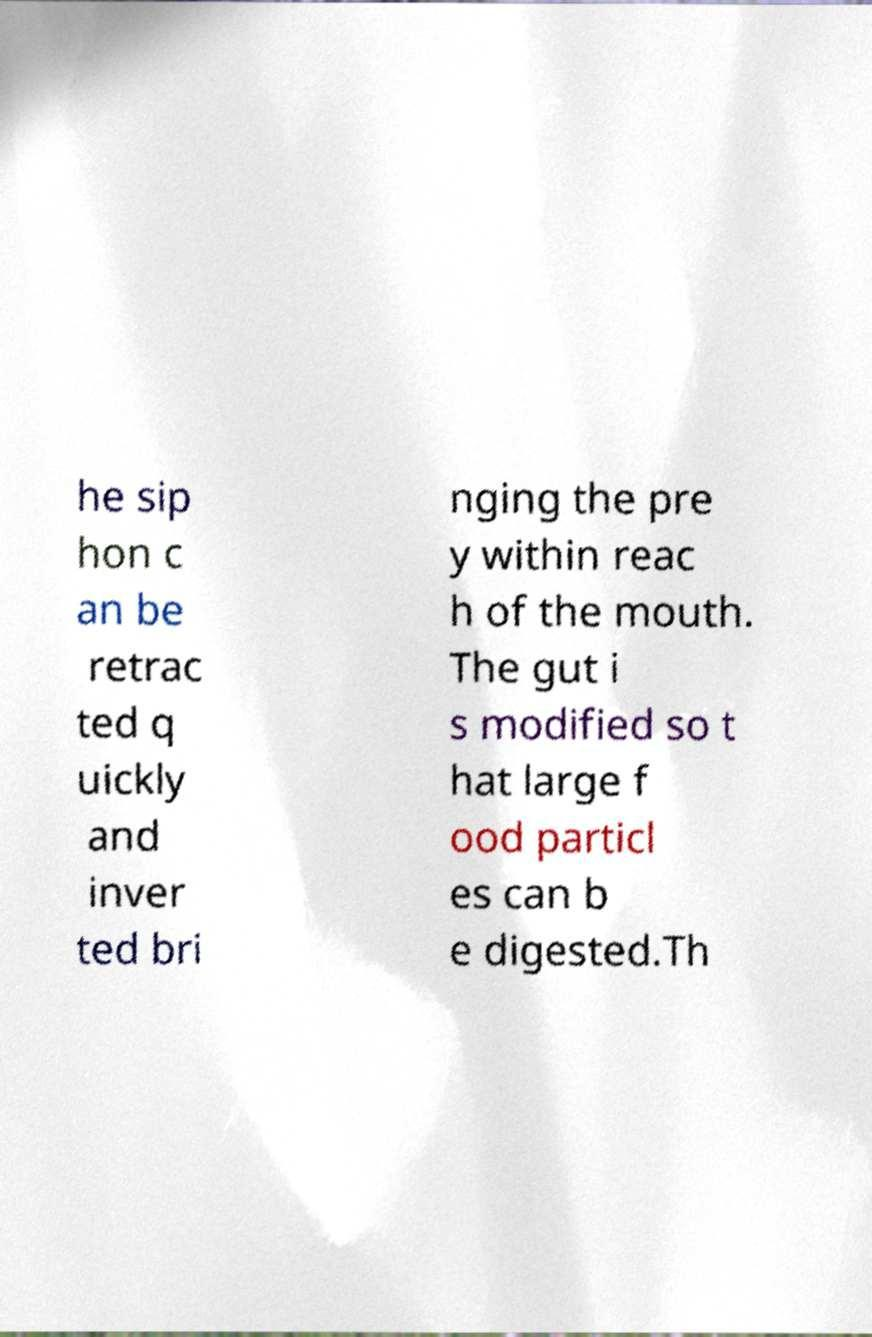Please identify and transcribe the text found in this image. he sip hon c an be retrac ted q uickly and inver ted bri nging the pre y within reac h of the mouth. The gut i s modified so t hat large f ood particl es can b e digested.Th 